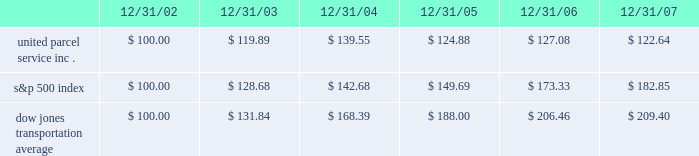Shareowner return performance graph the following performance graph and related information shall not be deemed 201csoliciting material 201d or to be 201cfiled 201d with the securities and exchange commission , nor shall such information be incorporated by reference into any future filing under the securities act of 1933 or securities exchange act of 1934 , each as amended , except to the extent that the company specifically incorporates such information by reference into such filing .
The following graph shows a five-year comparison of cumulative total shareowners 2019 returns for our class b common stock , the s&p 500 index , and the dow jones transportation average .
The comparison of the total cumulative return on investment , which is the change in the quarterly stock price plus reinvested dividends for each of the quarterly periods , assumes that $ 100 was invested on december 31 , 2002 in the s&p 500 index , the dow jones transportation average , and the class b common stock of united parcel service , inc .
Comparison of five year cumulative total return $ 40.00 $ 60.00 $ 80.00 $ 100.00 $ 120.00 $ 140.00 $ 160.00 $ 180.00 $ 200.00 $ 220.00 2002 20072006200520042003 s&p 500 ups dj transport .
Securities authorized for issuance under equity compensation plans the following table provides information as of december 31 , 2007 regarding compensation plans under which our class a common stock is authorized for issuance .
These plans do not authorize the issuance of our class b common stock. .
What was the percentage five year cumulative total return for united parcel service inc . for the period ended 12/31/07? 
Computations: ((122.64 - 100) / 100)
Answer: 0.2264. 